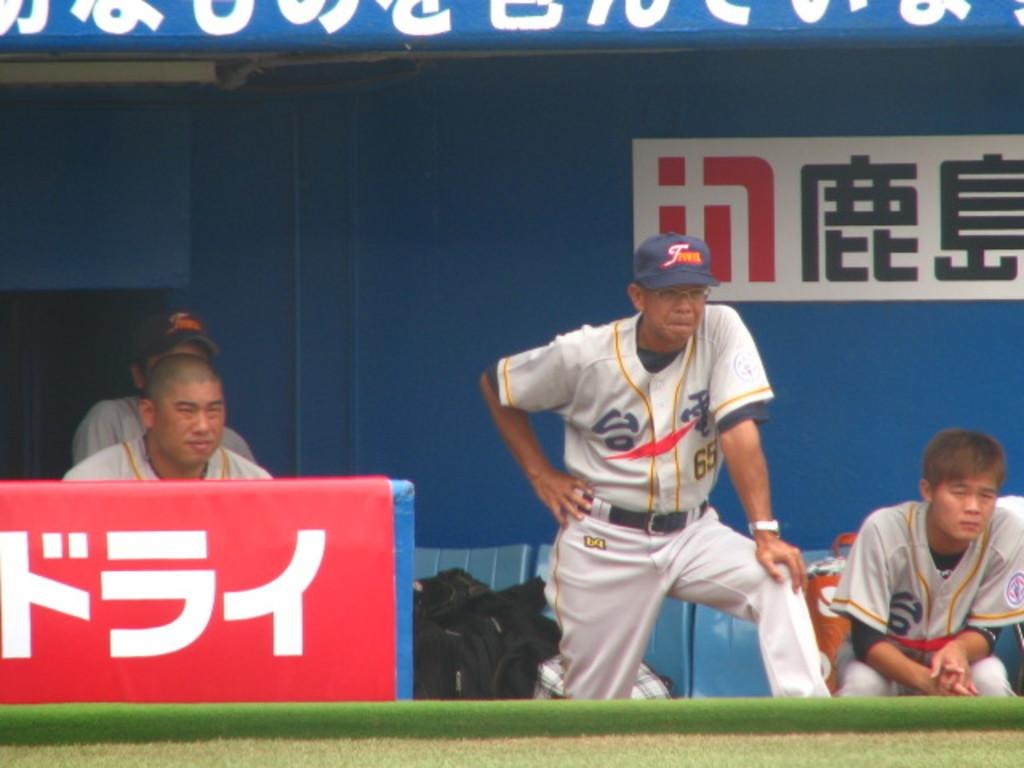<image>
Render a clear and concise summary of the photo. number 65 player is watching the game attentively 